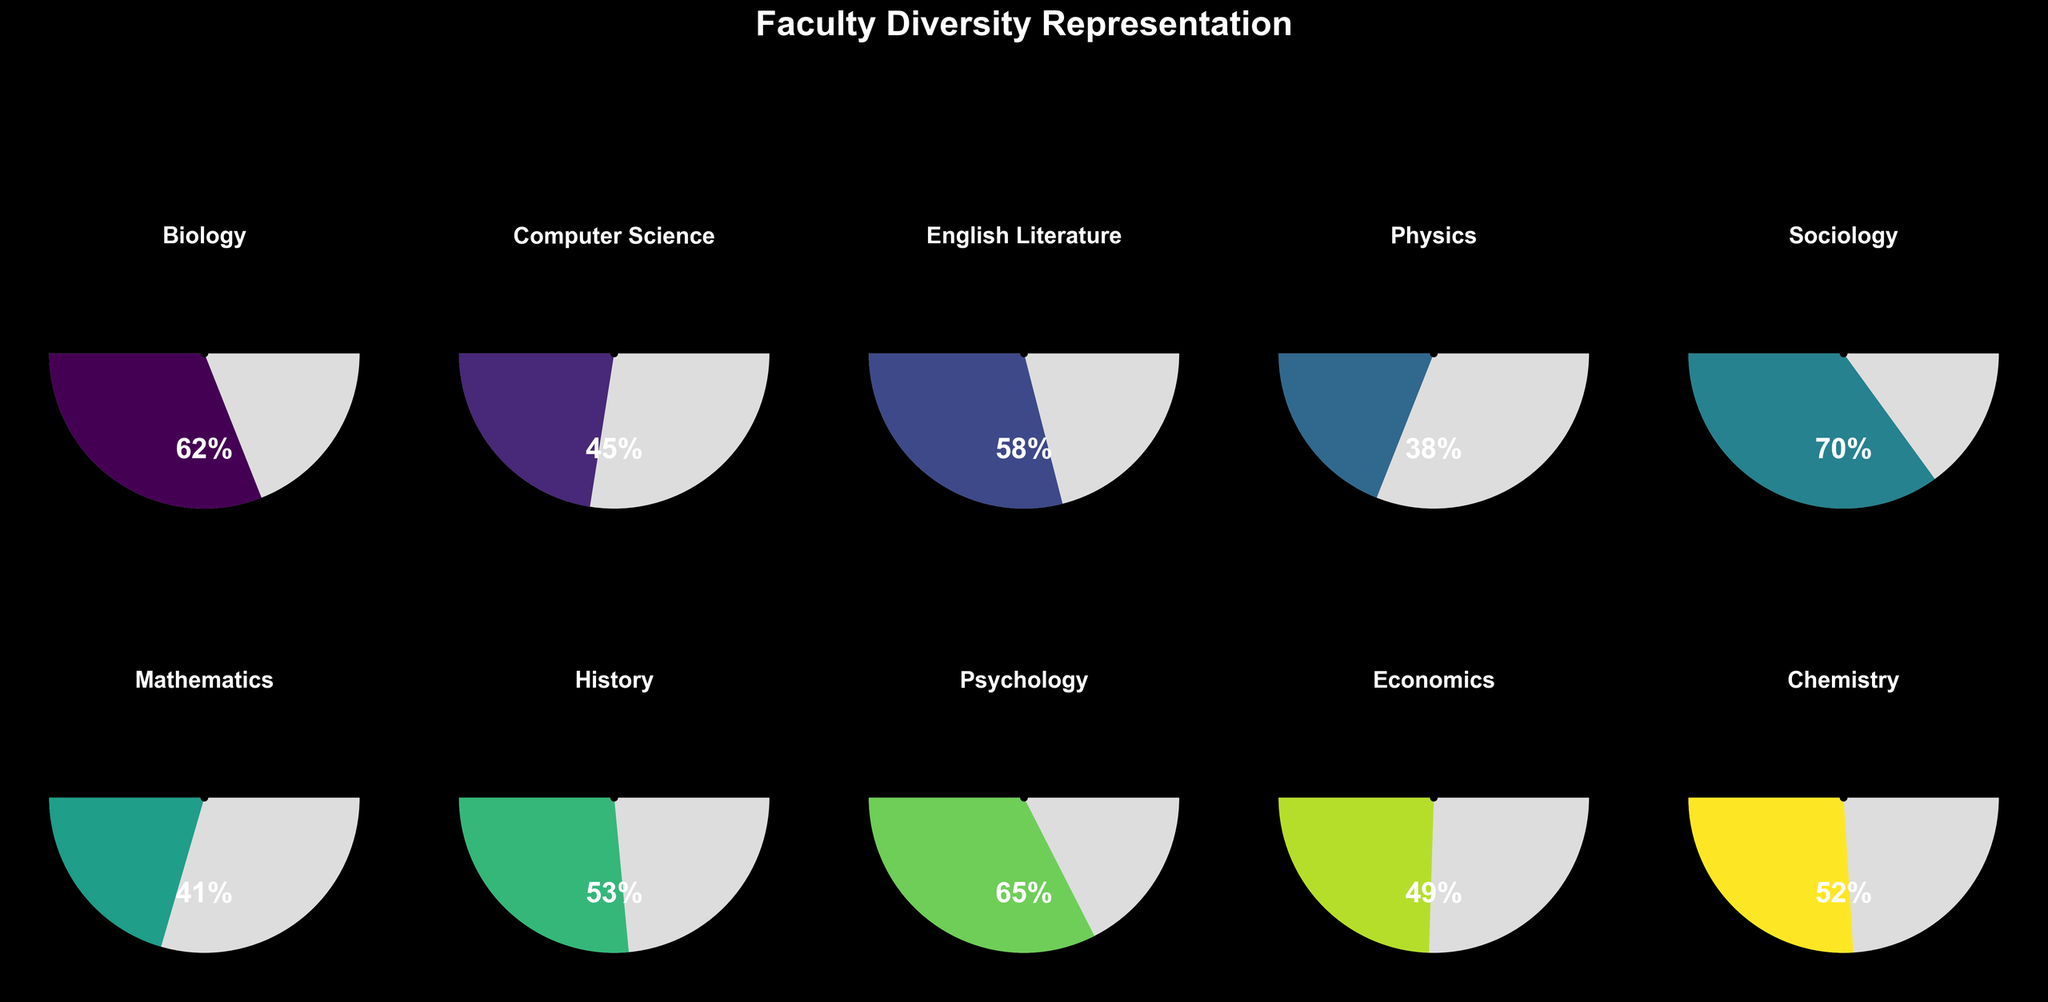What is the title of the figure? The title is typically placed at the top of the figure. This figure has "Faculty Diversity Representation" as its title.
Answer: Faculty Diversity Representation Which department has the highest diversity percentage? To find the department with the highest diversity percentage, look at all the values provided for each department and identify the highest one. Sociology has a percentage of 70%, which is the highest among all departments.
Answer: Sociology Which department demonstrates the lowest diversity percentage? Look at each department's diversity percentage and identify the lowest one. Physics, with a percentage of 38%, has the lowest diversity representation.
Answer: Physics What is the diversity percentage for the Computer Science department? Find the gauge corresponding to the Computer Science department and read the percentage shown. The gauge displays 45%.
Answer: 45% How many departments have a diversity percentage above 50%? Count the number of departments where the diversity percentage is greater than 50%. Those departments are Biology, English Literature, Sociology, History, Psychology, and Chemistry. There are 6 departments in total.
Answer: 6 What is the total sum of the diversity percentages across all departments? Add up all the individual diversity percentages given: 62 + 45 + 58 + 38 + 70 + 41 + 53 + 65 + 49 + 52. The total sum is 533.
Answer: 533 What is the average diversity percentage across all departments? To find the average, sum all the diversity percentages and divide by the number of departments: (62 + 45 + 58 + 38 + 70 + 41 + 53 + 65 + 49 + 52) / 10. The result is 533 / 10 = 53.3%.
Answer: 53.3% Which department is closest to the average diversity percentage? First, find the average diversity percentage (53.3%). Then identify the department's value closest to this average. The History department, with a percentage of 53%, is the closest.
Answer: History How many departments have a diversity percentage below 50%? Count the departments with diversity percentages below 50. These departments are Computer Science, Physics, and Mathematics. There are 3 departments in total.
Answer: 3 Which department's diversity percentage is exactly midway between the highest and lowest values? First, identify the highest (70%) and lowest (38%) diversity percentages. The midpoint is (70 + 38) / 2 = 54%. The Chemistry department, with a value of 52%, is closest to 54%.
Answer: Chemistry 